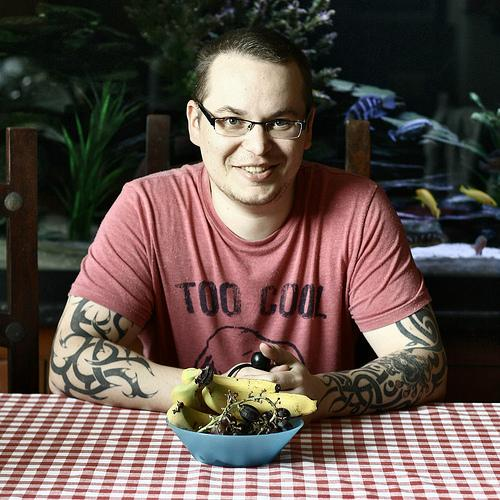What sort of diet might the person at the table have? vegan 